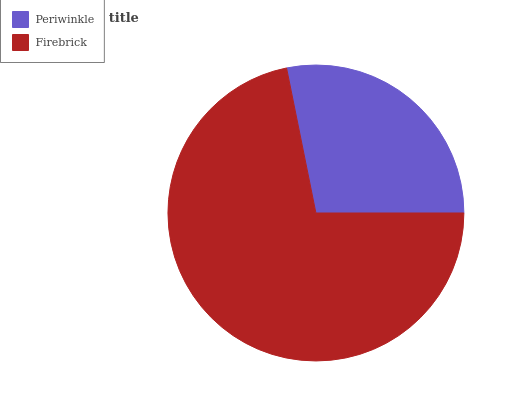Is Periwinkle the minimum?
Answer yes or no. Yes. Is Firebrick the maximum?
Answer yes or no. Yes. Is Firebrick the minimum?
Answer yes or no. No. Is Firebrick greater than Periwinkle?
Answer yes or no. Yes. Is Periwinkle less than Firebrick?
Answer yes or no. Yes. Is Periwinkle greater than Firebrick?
Answer yes or no. No. Is Firebrick less than Periwinkle?
Answer yes or no. No. Is Firebrick the high median?
Answer yes or no. Yes. Is Periwinkle the low median?
Answer yes or no. Yes. Is Periwinkle the high median?
Answer yes or no. No. Is Firebrick the low median?
Answer yes or no. No. 